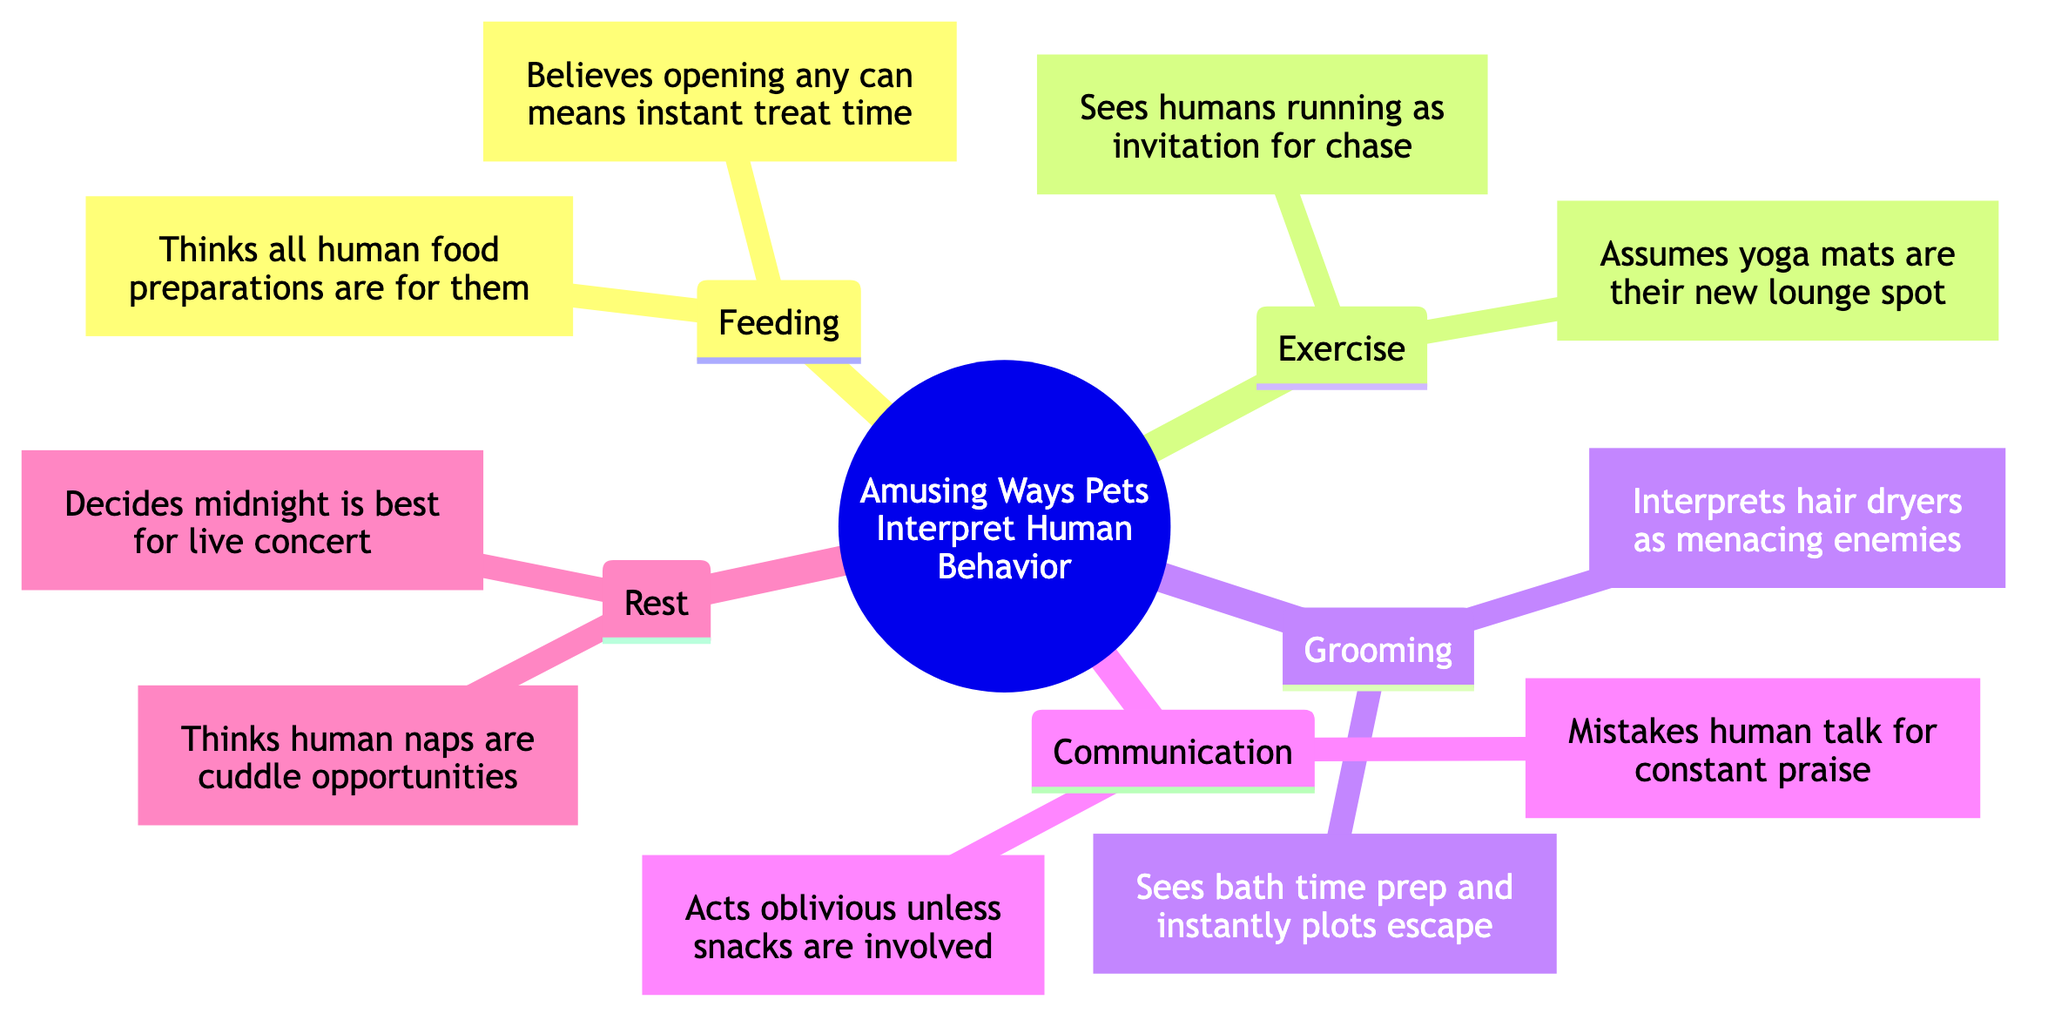What are the two subtopics under Feeding? The Feeding topic has two sub-elements listed: Dog thinks all human food preparations are for them and Cat believes opening any can means instant treat time.
Answer: Dog and Cat How does a dog interpret human exercise? According to the diagram, the Dog sees humans running as an invitation for a game of chase.
Answer: Invitation for chase What do cats think about yoga mats? The diagram indicates that Cats assume yoga mats are their new lounge spot.
Answer: New lounge spot How many main subtopics are there in the Mind Map? The Mind Map contains five main subtopics: Feeding, Exercise, Grooming, Communication, and Rest. Thus, the total is five.
Answer: 5 What do dogs believe about human naps? The diagram states that dogs think human naps are perfect cuddle opportunities.
Answer: Perfect cuddle opportunities Which pet interprets hair dryers as menacing enemies? The Mind Map specifies that the Dog interprets hair dryers as menacing enemies.
Answer: Dog What initiates a cat’s top priority in communication? From the diagram, night-time human calls are only acknowledged by Cats if snacks are involved.
Answer: Snacks What is the humorous interpretation of animals during grooming activities? The diagram highlights that both pets have humorous interpretations: Dog interprets hair dryers as enemies and Cat plots escape during bath time.
Answer: Hair dryers and escape How does the dog react to human conversation? The Dog mistakes human talk for constant praise and affection according to the Mind Map.
Answer: Constant praise 